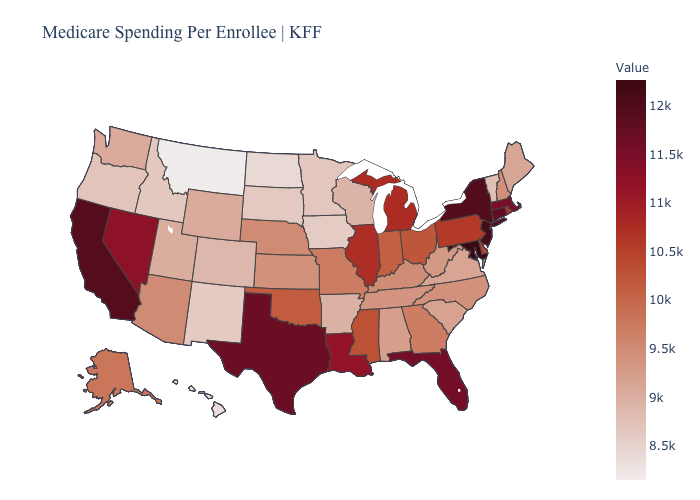Which states have the lowest value in the USA?
Concise answer only. Montana. Which states have the highest value in the USA?
Quick response, please. Maryland. Among the states that border Ohio , which have the lowest value?
Short answer required. West Virginia. Among the states that border Texas , which have the lowest value?
Short answer required. New Mexico. Does Louisiana have a higher value than Indiana?
Keep it brief. Yes. 